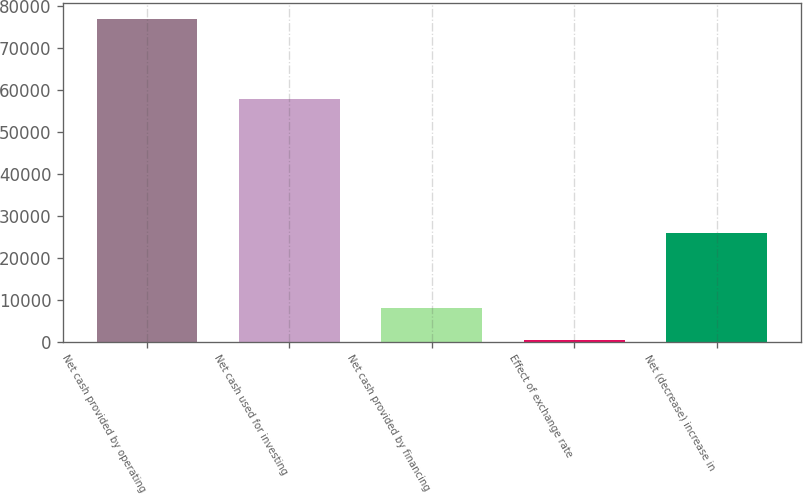Convert chart. <chart><loc_0><loc_0><loc_500><loc_500><bar_chart><fcel>Net cash provided by operating<fcel>Net cash used for investing<fcel>Net cash provided by financing<fcel>Effect of exchange rate<fcel>Net (decrease) increase in<nl><fcel>76795<fcel>57710<fcel>8053<fcel>415<fcel>25830<nl></chart> 